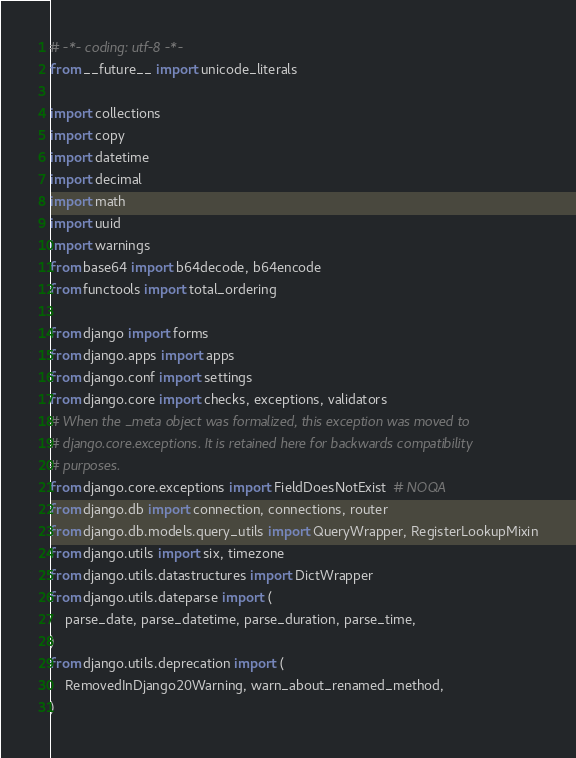<code> <loc_0><loc_0><loc_500><loc_500><_Python_># -*- coding: utf-8 -*-
from __future__ import unicode_literals

import collections
import copy
import datetime
import decimal
import math
import uuid
import warnings
from base64 import b64decode, b64encode
from functools import total_ordering

from django import forms
from django.apps import apps
from django.conf import settings
from django.core import checks, exceptions, validators
# When the _meta object was formalized, this exception was moved to
# django.core.exceptions. It is retained here for backwards compatibility
# purposes.
from django.core.exceptions import FieldDoesNotExist  # NOQA
from django.db import connection, connections, router
from django.db.models.query_utils import QueryWrapper, RegisterLookupMixin
from django.utils import six, timezone
from django.utils.datastructures import DictWrapper
from django.utils.dateparse import (
    parse_date, parse_datetime, parse_duration, parse_time,
)
from django.utils.deprecation import (
    RemovedInDjango20Warning, warn_about_renamed_method,
)</code> 